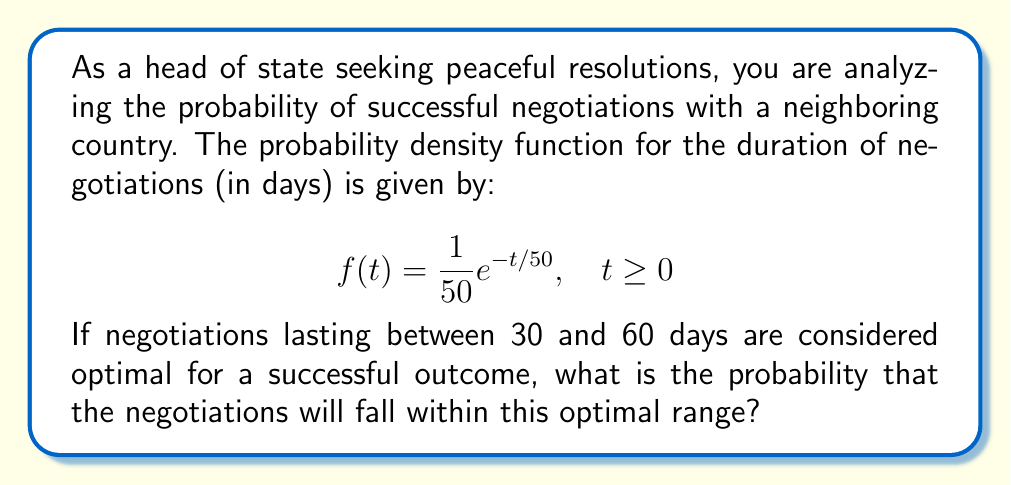Teach me how to tackle this problem. To solve this problem, we need to integrate the probability density function over the given interval. Here's the step-by-step solution:

1) The probability of an event occurring within a specific interval is given by the integral of the probability density function over that interval. In this case, we need to integrate $f(t)$ from 30 to 60.

2) Set up the integral:

   $$P(30 \leq t \leq 60) = \int_{30}^{60} \frac{1}{50}e^{-t/50} dt$$

3) To solve this integral, we can use the substitution method:
   Let $u = -t/50$, then $du = -\frac{1}{50}dt$
   When $t = 30$, $u = -3/5$
   When $t = 60$, $u = -6/5$

4) Rewrite the integral in terms of $u$:

   $$\int_{30}^{60} \frac{1}{50}e^{-t/50} dt = \int_{-6/5}^{-3/5} e^u (-50du) = 50\int_{-6/5}^{-3/5} e^u du$$

5) Solve the integral:

   $$50\int_{-6/5}^{-3/5} e^u du = 50[e^u]_{-6/5}^{-3/5} = 50(e^{-3/5} - e^{-6/5})$$

6) Calculate the final result:

   $$50(e^{-3/5} - e^{-6/5}) \approx 0.1812$$

Therefore, the probability that the negotiations will last between 30 and 60 days is approximately 0.1812 or 18.12%.
Answer: The probability that the negotiations will fall within the optimal range of 30 to 60 days is approximately 0.1812 or 18.12%. 